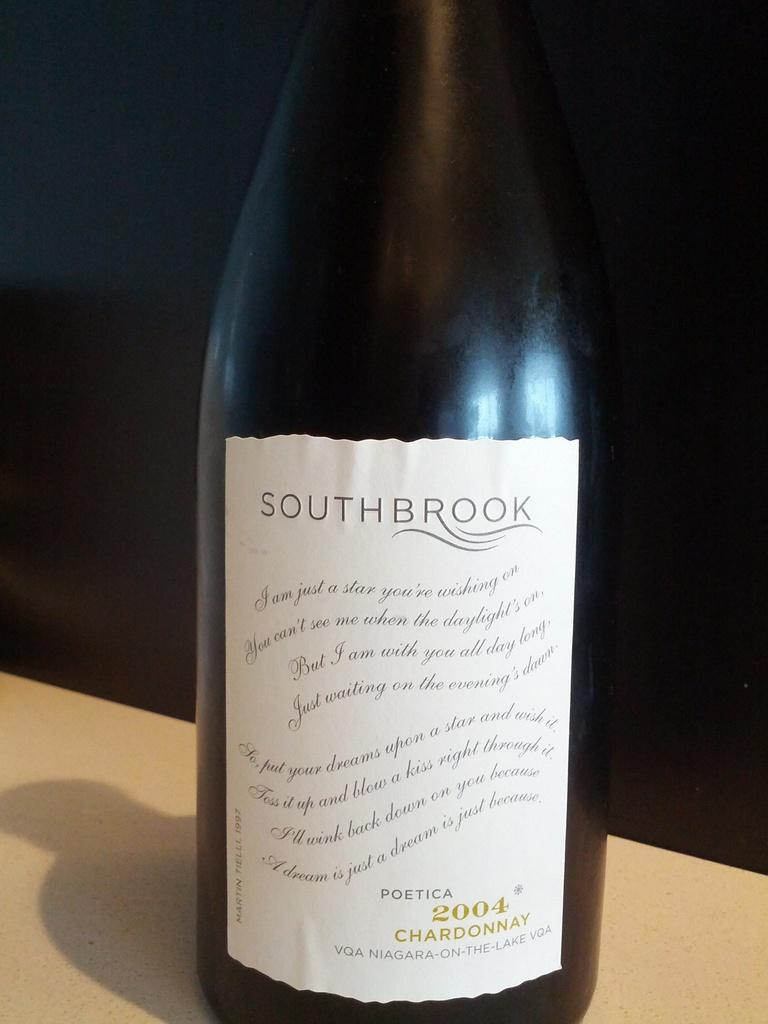<image>
Offer a succinct explanation of the picture presented. the name Southbrook that is on a wine bottle 